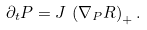Convert formula to latex. <formula><loc_0><loc_0><loc_500><loc_500>\partial _ { t } P = J \, \left ( \nabla _ { P } R \right ) _ { + } .</formula> 